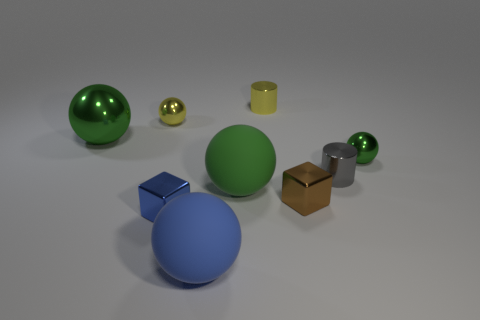There is a big shiny thing; does it have the same color as the ball that is to the right of the tiny brown object?
Your answer should be compact. Yes. Are there fewer small yellow balls that are on the right side of the tiny blue metallic object than tiny blue blocks?
Your answer should be very brief. Yes. What material is the blue ball that is on the left side of the yellow cylinder?
Your answer should be compact. Rubber. How many other things are there of the same size as the gray cylinder?
Give a very brief answer. 5. There is a blue shiny block; is it the same size as the brown block that is right of the tiny yellow shiny cylinder?
Provide a succinct answer. Yes. There is a green metallic object in front of the big green sphere that is left of the tiny blue object that is in front of the brown object; what is its shape?
Give a very brief answer. Sphere. Are there fewer green metal balls than brown objects?
Make the answer very short. No. Are there any yellow metal things in front of the big green metal thing?
Keep it short and to the point. No. What shape is the green object that is behind the gray shiny object and left of the small green metallic thing?
Your answer should be very brief. Sphere. Is there another thing that has the same shape as the tiny blue object?
Make the answer very short. Yes. 